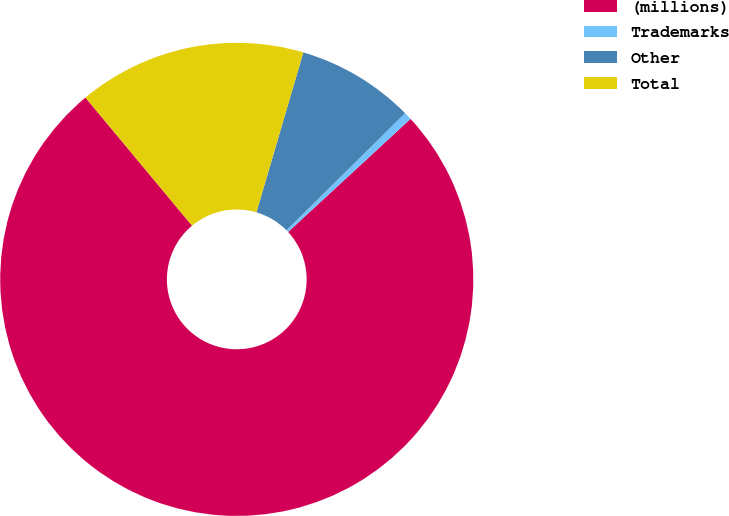<chart> <loc_0><loc_0><loc_500><loc_500><pie_chart><fcel>(millions)<fcel>Trademarks<fcel>Other<fcel>Total<nl><fcel>75.83%<fcel>0.53%<fcel>8.06%<fcel>15.59%<nl></chart> 